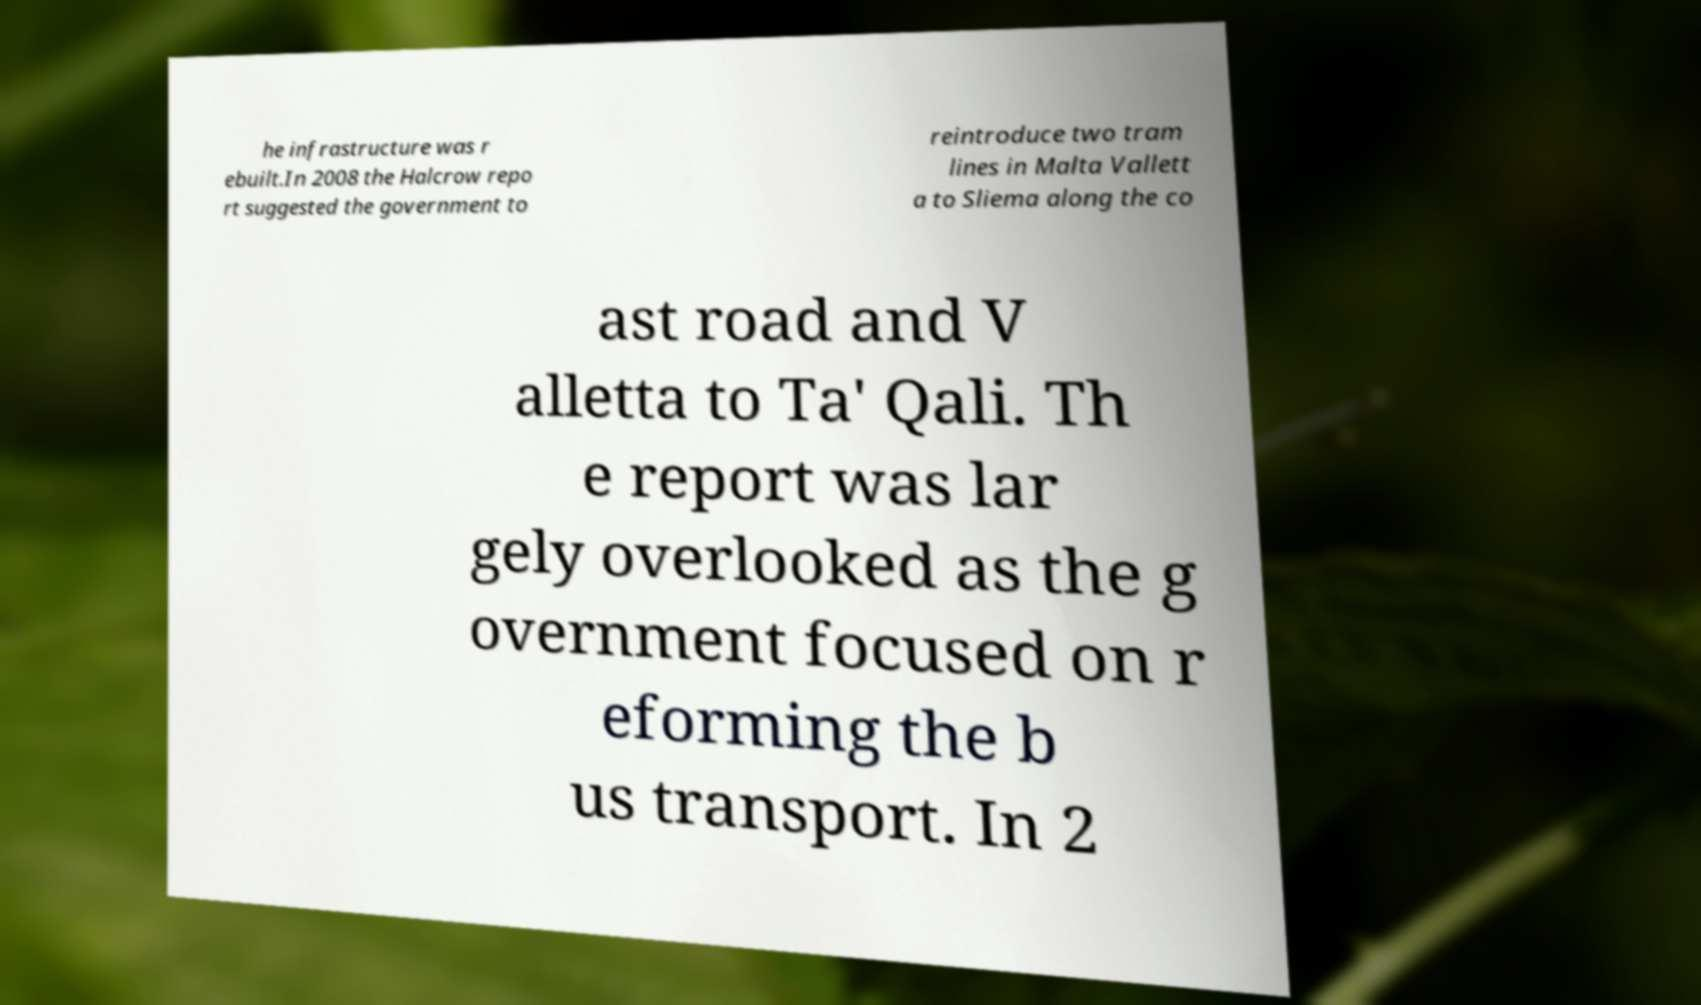There's text embedded in this image that I need extracted. Can you transcribe it verbatim? he infrastructure was r ebuilt.In 2008 the Halcrow repo rt suggested the government to reintroduce two tram lines in Malta Vallett a to Sliema along the co ast road and V alletta to Ta' Qali. Th e report was lar gely overlooked as the g overnment focused on r eforming the b us transport. In 2 